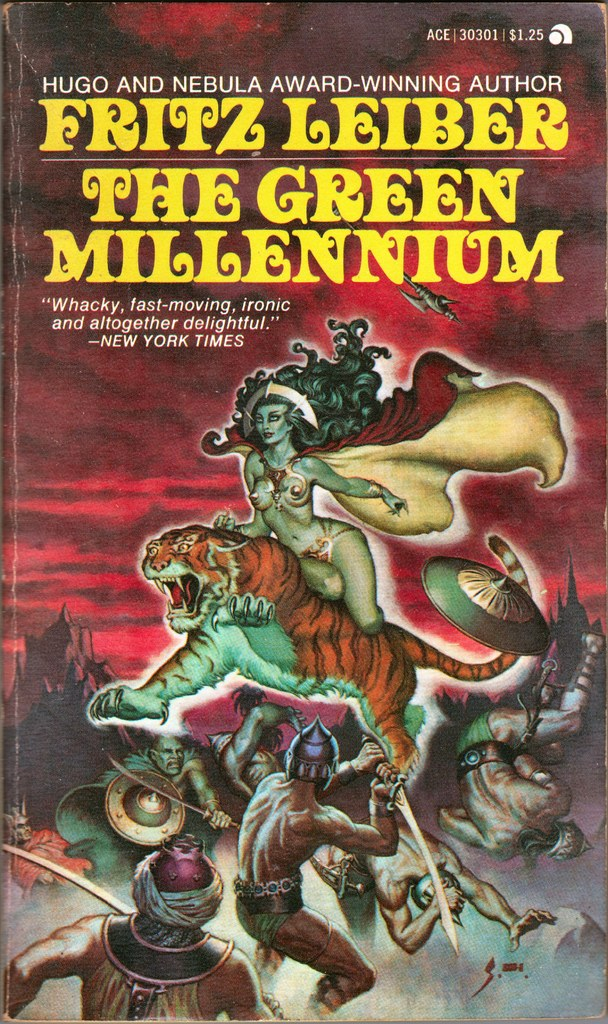What might the symbolism of a woman riding a tiger against a backdrop of battle represent in this book's context? The imagery of a woman riding a tiger in 'The Green Millennium' might symbolize a powerful, perhaps mystical influence guiding or disrupting the more mundane or chaotic activities of the human warriors below. It could represent themes of dominance, protection, or the intervention of the supernatural in the human realm, aligning with speculative fiction’s often thematic exploration of extraordinary situations impacting normal societal structures. 